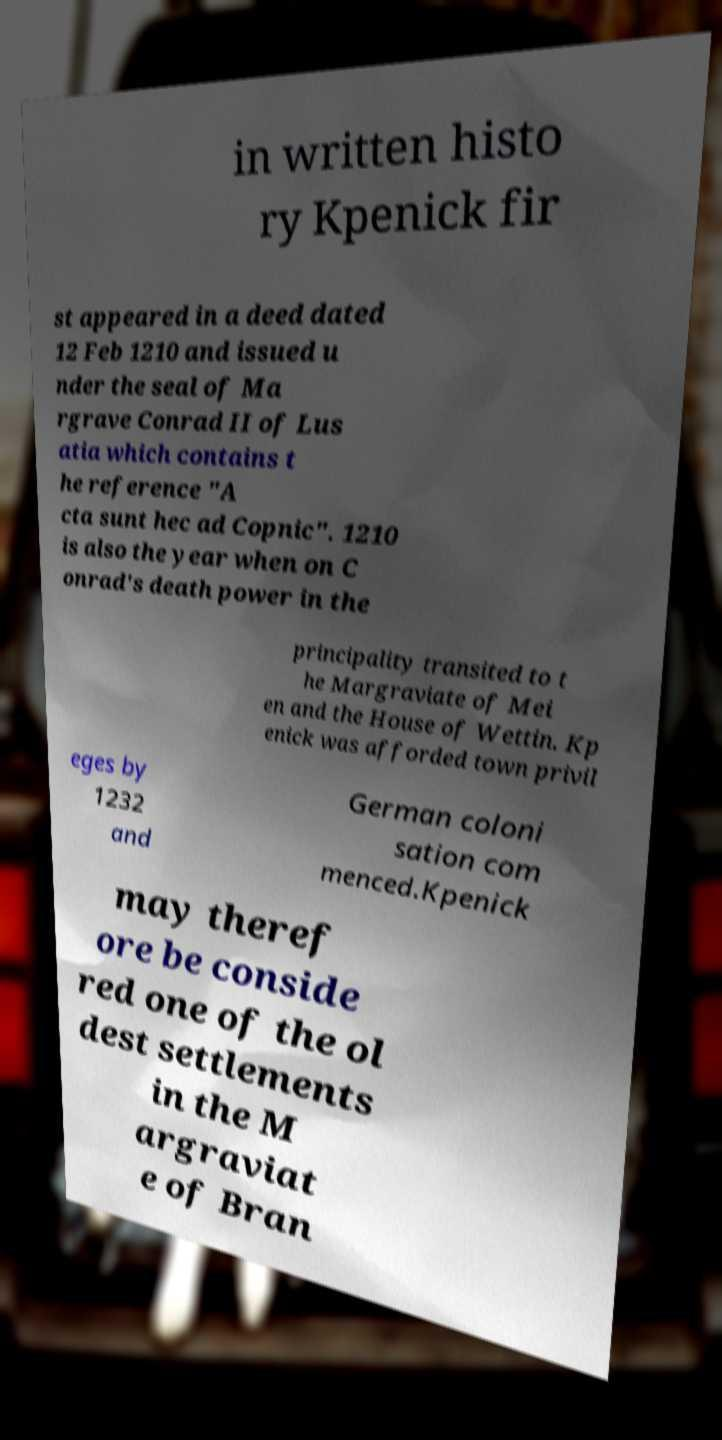There's text embedded in this image that I need extracted. Can you transcribe it verbatim? in written histo ry Kpenick fir st appeared in a deed dated 12 Feb 1210 and issued u nder the seal of Ma rgrave Conrad II of Lus atia which contains t he reference "A cta sunt hec ad Copnic". 1210 is also the year when on C onrad's death power in the principality transited to t he Margraviate of Mei en and the House of Wettin. Kp enick was afforded town privil eges by 1232 and German coloni sation com menced.Kpenick may theref ore be conside red one of the ol dest settlements in the M argraviat e of Bran 